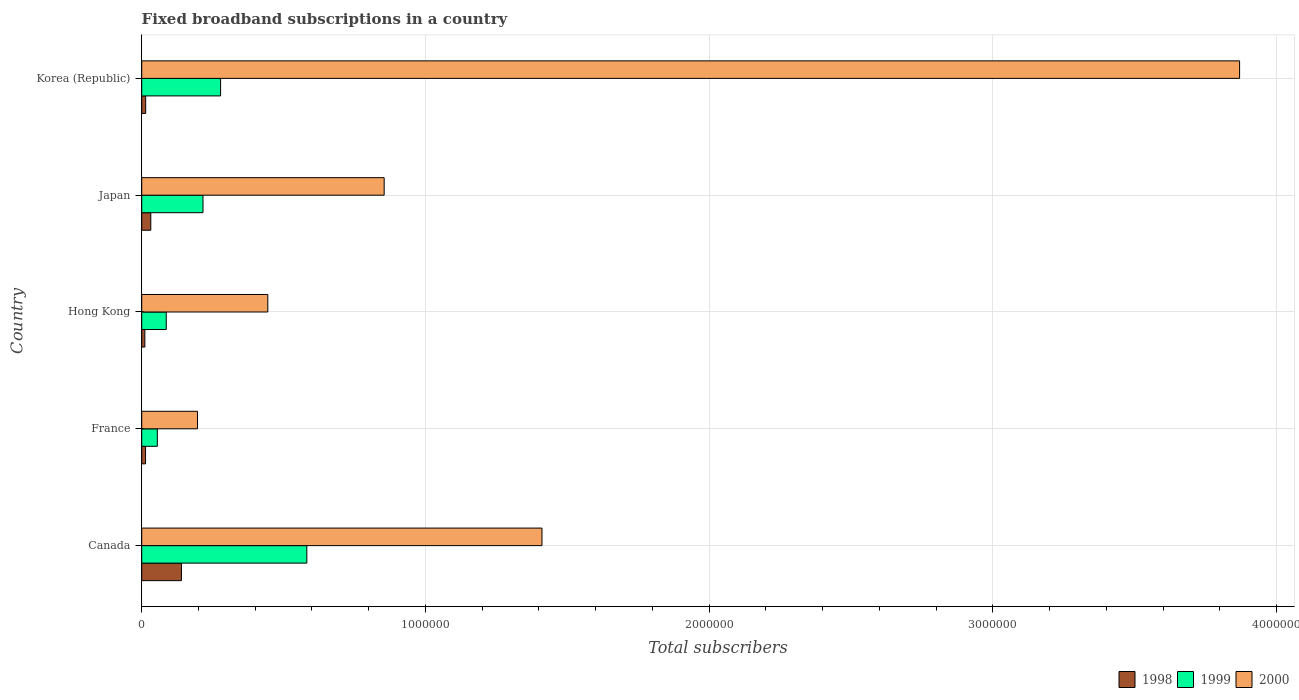Are the number of bars on each tick of the Y-axis equal?
Provide a succinct answer. Yes. How many bars are there on the 5th tick from the top?
Give a very brief answer. 3. What is the label of the 1st group of bars from the top?
Your answer should be compact. Korea (Republic). What is the number of broadband subscriptions in 2000 in France?
Offer a very short reply. 1.97e+05. Across all countries, what is the minimum number of broadband subscriptions in 2000?
Your answer should be compact. 1.97e+05. In which country was the number of broadband subscriptions in 2000 maximum?
Make the answer very short. Korea (Republic). In which country was the number of broadband subscriptions in 2000 minimum?
Give a very brief answer. France. What is the total number of broadband subscriptions in 1999 in the graph?
Offer a very short reply. 1.22e+06. What is the difference between the number of broadband subscriptions in 1998 in France and that in Japan?
Give a very brief answer. -1.85e+04. What is the difference between the number of broadband subscriptions in 1998 in Canada and the number of broadband subscriptions in 1999 in Hong Kong?
Give a very brief answer. 5.35e+04. What is the average number of broadband subscriptions in 1999 per country?
Your answer should be compact. 2.43e+05. What is the difference between the number of broadband subscriptions in 1999 and number of broadband subscriptions in 1998 in Canada?
Offer a very short reply. 4.42e+05. In how many countries, is the number of broadband subscriptions in 2000 greater than 1200000 ?
Ensure brevity in your answer.  2. What is the ratio of the number of broadband subscriptions in 1999 in Canada to that in France?
Make the answer very short. 10.58. Is the number of broadband subscriptions in 1999 in France less than that in Japan?
Make the answer very short. Yes. What is the difference between the highest and the second highest number of broadband subscriptions in 1999?
Ensure brevity in your answer.  3.04e+05. What is the difference between the highest and the lowest number of broadband subscriptions in 1999?
Offer a terse response. 5.27e+05. In how many countries, is the number of broadband subscriptions in 1999 greater than the average number of broadband subscriptions in 1999 taken over all countries?
Offer a very short reply. 2. Is the sum of the number of broadband subscriptions in 2000 in France and Korea (Republic) greater than the maximum number of broadband subscriptions in 1999 across all countries?
Keep it short and to the point. Yes. What does the 3rd bar from the top in Japan represents?
Provide a short and direct response. 1998. What does the 2nd bar from the bottom in Canada represents?
Offer a very short reply. 1999. Is it the case that in every country, the sum of the number of broadband subscriptions in 2000 and number of broadband subscriptions in 1998 is greater than the number of broadband subscriptions in 1999?
Your answer should be very brief. Yes. What is the difference between two consecutive major ticks on the X-axis?
Ensure brevity in your answer.  1.00e+06. Are the values on the major ticks of X-axis written in scientific E-notation?
Ensure brevity in your answer.  No. What is the title of the graph?
Offer a terse response. Fixed broadband subscriptions in a country. What is the label or title of the X-axis?
Make the answer very short. Total subscribers. What is the Total subscribers of 1998 in Canada?
Your response must be concise. 1.40e+05. What is the Total subscribers of 1999 in Canada?
Keep it short and to the point. 5.82e+05. What is the Total subscribers in 2000 in Canada?
Your answer should be very brief. 1.41e+06. What is the Total subscribers of 1998 in France?
Offer a terse response. 1.35e+04. What is the Total subscribers of 1999 in France?
Ensure brevity in your answer.  5.50e+04. What is the Total subscribers of 2000 in France?
Your answer should be compact. 1.97e+05. What is the Total subscribers of 1998 in Hong Kong?
Your response must be concise. 1.10e+04. What is the Total subscribers in 1999 in Hong Kong?
Your response must be concise. 8.65e+04. What is the Total subscribers in 2000 in Hong Kong?
Provide a succinct answer. 4.44e+05. What is the Total subscribers in 1998 in Japan?
Provide a succinct answer. 3.20e+04. What is the Total subscribers of 1999 in Japan?
Make the answer very short. 2.16e+05. What is the Total subscribers of 2000 in Japan?
Provide a short and direct response. 8.55e+05. What is the Total subscribers in 1998 in Korea (Republic)?
Your response must be concise. 1.40e+04. What is the Total subscribers of 1999 in Korea (Republic)?
Offer a terse response. 2.78e+05. What is the Total subscribers of 2000 in Korea (Republic)?
Your response must be concise. 3.87e+06. Across all countries, what is the maximum Total subscribers in 1999?
Offer a very short reply. 5.82e+05. Across all countries, what is the maximum Total subscribers in 2000?
Provide a succinct answer. 3.87e+06. Across all countries, what is the minimum Total subscribers of 1998?
Provide a succinct answer. 1.10e+04. Across all countries, what is the minimum Total subscribers of 1999?
Your response must be concise. 5.50e+04. Across all countries, what is the minimum Total subscribers of 2000?
Your answer should be very brief. 1.97e+05. What is the total Total subscribers in 1998 in the graph?
Your response must be concise. 2.10e+05. What is the total Total subscribers of 1999 in the graph?
Your response must be concise. 1.22e+06. What is the total Total subscribers of 2000 in the graph?
Your answer should be very brief. 6.78e+06. What is the difference between the Total subscribers in 1998 in Canada and that in France?
Give a very brief answer. 1.27e+05. What is the difference between the Total subscribers of 1999 in Canada and that in France?
Keep it short and to the point. 5.27e+05. What is the difference between the Total subscribers in 2000 in Canada and that in France?
Make the answer very short. 1.21e+06. What is the difference between the Total subscribers in 1998 in Canada and that in Hong Kong?
Offer a terse response. 1.29e+05. What is the difference between the Total subscribers in 1999 in Canada and that in Hong Kong?
Provide a short and direct response. 4.96e+05. What is the difference between the Total subscribers in 2000 in Canada and that in Hong Kong?
Give a very brief answer. 9.66e+05. What is the difference between the Total subscribers in 1998 in Canada and that in Japan?
Offer a terse response. 1.08e+05. What is the difference between the Total subscribers in 1999 in Canada and that in Japan?
Provide a succinct answer. 3.66e+05. What is the difference between the Total subscribers of 2000 in Canada and that in Japan?
Make the answer very short. 5.56e+05. What is the difference between the Total subscribers of 1998 in Canada and that in Korea (Republic)?
Your answer should be compact. 1.26e+05. What is the difference between the Total subscribers in 1999 in Canada and that in Korea (Republic)?
Keep it short and to the point. 3.04e+05. What is the difference between the Total subscribers in 2000 in Canada and that in Korea (Republic)?
Your answer should be very brief. -2.46e+06. What is the difference between the Total subscribers in 1998 in France and that in Hong Kong?
Provide a short and direct response. 2464. What is the difference between the Total subscribers of 1999 in France and that in Hong Kong?
Make the answer very short. -3.15e+04. What is the difference between the Total subscribers of 2000 in France and that in Hong Kong?
Provide a succinct answer. -2.48e+05. What is the difference between the Total subscribers in 1998 in France and that in Japan?
Provide a short and direct response. -1.85e+04. What is the difference between the Total subscribers of 1999 in France and that in Japan?
Make the answer very short. -1.61e+05. What is the difference between the Total subscribers in 2000 in France and that in Japan?
Offer a very short reply. -6.58e+05. What is the difference between the Total subscribers in 1998 in France and that in Korea (Republic)?
Offer a terse response. -536. What is the difference between the Total subscribers of 1999 in France and that in Korea (Republic)?
Your response must be concise. -2.23e+05. What is the difference between the Total subscribers in 2000 in France and that in Korea (Republic)?
Keep it short and to the point. -3.67e+06. What is the difference between the Total subscribers of 1998 in Hong Kong and that in Japan?
Give a very brief answer. -2.10e+04. What is the difference between the Total subscribers in 1999 in Hong Kong and that in Japan?
Your answer should be very brief. -1.30e+05. What is the difference between the Total subscribers in 2000 in Hong Kong and that in Japan?
Offer a very short reply. -4.10e+05. What is the difference between the Total subscribers in 1998 in Hong Kong and that in Korea (Republic)?
Offer a very short reply. -3000. What is the difference between the Total subscribers of 1999 in Hong Kong and that in Korea (Republic)?
Ensure brevity in your answer.  -1.92e+05. What is the difference between the Total subscribers of 2000 in Hong Kong and that in Korea (Republic)?
Your answer should be compact. -3.43e+06. What is the difference between the Total subscribers in 1998 in Japan and that in Korea (Republic)?
Ensure brevity in your answer.  1.80e+04. What is the difference between the Total subscribers in 1999 in Japan and that in Korea (Republic)?
Provide a succinct answer. -6.20e+04. What is the difference between the Total subscribers in 2000 in Japan and that in Korea (Republic)?
Give a very brief answer. -3.02e+06. What is the difference between the Total subscribers in 1998 in Canada and the Total subscribers in 1999 in France?
Provide a succinct answer. 8.50e+04. What is the difference between the Total subscribers of 1998 in Canada and the Total subscribers of 2000 in France?
Make the answer very short. -5.66e+04. What is the difference between the Total subscribers in 1999 in Canada and the Total subscribers in 2000 in France?
Your answer should be very brief. 3.85e+05. What is the difference between the Total subscribers in 1998 in Canada and the Total subscribers in 1999 in Hong Kong?
Offer a terse response. 5.35e+04. What is the difference between the Total subscribers in 1998 in Canada and the Total subscribers in 2000 in Hong Kong?
Your response must be concise. -3.04e+05. What is the difference between the Total subscribers in 1999 in Canada and the Total subscribers in 2000 in Hong Kong?
Your response must be concise. 1.38e+05. What is the difference between the Total subscribers of 1998 in Canada and the Total subscribers of 1999 in Japan?
Your response must be concise. -7.60e+04. What is the difference between the Total subscribers of 1998 in Canada and the Total subscribers of 2000 in Japan?
Your answer should be compact. -7.15e+05. What is the difference between the Total subscribers in 1999 in Canada and the Total subscribers in 2000 in Japan?
Provide a short and direct response. -2.73e+05. What is the difference between the Total subscribers in 1998 in Canada and the Total subscribers in 1999 in Korea (Republic)?
Your answer should be very brief. -1.38e+05. What is the difference between the Total subscribers of 1998 in Canada and the Total subscribers of 2000 in Korea (Republic)?
Your answer should be very brief. -3.73e+06. What is the difference between the Total subscribers of 1999 in Canada and the Total subscribers of 2000 in Korea (Republic)?
Ensure brevity in your answer.  -3.29e+06. What is the difference between the Total subscribers in 1998 in France and the Total subscribers in 1999 in Hong Kong?
Provide a succinct answer. -7.30e+04. What is the difference between the Total subscribers of 1998 in France and the Total subscribers of 2000 in Hong Kong?
Keep it short and to the point. -4.31e+05. What is the difference between the Total subscribers in 1999 in France and the Total subscribers in 2000 in Hong Kong?
Provide a succinct answer. -3.89e+05. What is the difference between the Total subscribers of 1998 in France and the Total subscribers of 1999 in Japan?
Your answer should be compact. -2.03e+05. What is the difference between the Total subscribers in 1998 in France and the Total subscribers in 2000 in Japan?
Your answer should be compact. -8.41e+05. What is the difference between the Total subscribers of 1999 in France and the Total subscribers of 2000 in Japan?
Keep it short and to the point. -8.00e+05. What is the difference between the Total subscribers in 1998 in France and the Total subscribers in 1999 in Korea (Republic)?
Ensure brevity in your answer.  -2.65e+05. What is the difference between the Total subscribers in 1998 in France and the Total subscribers in 2000 in Korea (Republic)?
Provide a short and direct response. -3.86e+06. What is the difference between the Total subscribers in 1999 in France and the Total subscribers in 2000 in Korea (Republic)?
Provide a short and direct response. -3.82e+06. What is the difference between the Total subscribers of 1998 in Hong Kong and the Total subscribers of 1999 in Japan?
Provide a short and direct response. -2.05e+05. What is the difference between the Total subscribers of 1998 in Hong Kong and the Total subscribers of 2000 in Japan?
Offer a very short reply. -8.44e+05. What is the difference between the Total subscribers of 1999 in Hong Kong and the Total subscribers of 2000 in Japan?
Give a very brief answer. -7.68e+05. What is the difference between the Total subscribers of 1998 in Hong Kong and the Total subscribers of 1999 in Korea (Republic)?
Keep it short and to the point. -2.67e+05. What is the difference between the Total subscribers in 1998 in Hong Kong and the Total subscribers in 2000 in Korea (Republic)?
Give a very brief answer. -3.86e+06. What is the difference between the Total subscribers of 1999 in Hong Kong and the Total subscribers of 2000 in Korea (Republic)?
Ensure brevity in your answer.  -3.78e+06. What is the difference between the Total subscribers of 1998 in Japan and the Total subscribers of 1999 in Korea (Republic)?
Your answer should be very brief. -2.46e+05. What is the difference between the Total subscribers in 1998 in Japan and the Total subscribers in 2000 in Korea (Republic)?
Offer a terse response. -3.84e+06. What is the difference between the Total subscribers in 1999 in Japan and the Total subscribers in 2000 in Korea (Republic)?
Make the answer very short. -3.65e+06. What is the average Total subscribers of 1998 per country?
Keep it short and to the point. 4.21e+04. What is the average Total subscribers in 1999 per country?
Provide a succinct answer. 2.43e+05. What is the average Total subscribers in 2000 per country?
Ensure brevity in your answer.  1.36e+06. What is the difference between the Total subscribers of 1998 and Total subscribers of 1999 in Canada?
Your response must be concise. -4.42e+05. What is the difference between the Total subscribers of 1998 and Total subscribers of 2000 in Canada?
Offer a terse response. -1.27e+06. What is the difference between the Total subscribers in 1999 and Total subscribers in 2000 in Canada?
Provide a short and direct response. -8.29e+05. What is the difference between the Total subscribers in 1998 and Total subscribers in 1999 in France?
Offer a very short reply. -4.15e+04. What is the difference between the Total subscribers in 1998 and Total subscribers in 2000 in France?
Keep it short and to the point. -1.83e+05. What is the difference between the Total subscribers in 1999 and Total subscribers in 2000 in France?
Your answer should be very brief. -1.42e+05. What is the difference between the Total subscribers of 1998 and Total subscribers of 1999 in Hong Kong?
Ensure brevity in your answer.  -7.55e+04. What is the difference between the Total subscribers of 1998 and Total subscribers of 2000 in Hong Kong?
Make the answer very short. -4.33e+05. What is the difference between the Total subscribers in 1999 and Total subscribers in 2000 in Hong Kong?
Offer a terse response. -3.58e+05. What is the difference between the Total subscribers in 1998 and Total subscribers in 1999 in Japan?
Ensure brevity in your answer.  -1.84e+05. What is the difference between the Total subscribers in 1998 and Total subscribers in 2000 in Japan?
Offer a terse response. -8.23e+05. What is the difference between the Total subscribers in 1999 and Total subscribers in 2000 in Japan?
Your answer should be compact. -6.39e+05. What is the difference between the Total subscribers in 1998 and Total subscribers in 1999 in Korea (Republic)?
Provide a succinct answer. -2.64e+05. What is the difference between the Total subscribers of 1998 and Total subscribers of 2000 in Korea (Republic)?
Provide a short and direct response. -3.86e+06. What is the difference between the Total subscribers of 1999 and Total subscribers of 2000 in Korea (Republic)?
Your answer should be very brief. -3.59e+06. What is the ratio of the Total subscribers of 1998 in Canada to that in France?
Offer a very short reply. 10.4. What is the ratio of the Total subscribers of 1999 in Canada to that in France?
Provide a succinct answer. 10.58. What is the ratio of the Total subscribers of 2000 in Canada to that in France?
Keep it short and to the point. 7.18. What is the ratio of the Total subscribers of 1998 in Canada to that in Hong Kong?
Make the answer very short. 12.73. What is the ratio of the Total subscribers of 1999 in Canada to that in Hong Kong?
Your answer should be compact. 6.73. What is the ratio of the Total subscribers in 2000 in Canada to that in Hong Kong?
Offer a terse response. 3.17. What is the ratio of the Total subscribers in 1998 in Canada to that in Japan?
Your answer should be compact. 4.38. What is the ratio of the Total subscribers in 1999 in Canada to that in Japan?
Offer a terse response. 2.69. What is the ratio of the Total subscribers of 2000 in Canada to that in Japan?
Make the answer very short. 1.65. What is the ratio of the Total subscribers of 1999 in Canada to that in Korea (Republic)?
Ensure brevity in your answer.  2.09. What is the ratio of the Total subscribers in 2000 in Canada to that in Korea (Republic)?
Offer a very short reply. 0.36. What is the ratio of the Total subscribers of 1998 in France to that in Hong Kong?
Provide a short and direct response. 1.22. What is the ratio of the Total subscribers in 1999 in France to that in Hong Kong?
Provide a succinct answer. 0.64. What is the ratio of the Total subscribers of 2000 in France to that in Hong Kong?
Make the answer very short. 0.44. What is the ratio of the Total subscribers of 1998 in France to that in Japan?
Keep it short and to the point. 0.42. What is the ratio of the Total subscribers of 1999 in France to that in Japan?
Your response must be concise. 0.25. What is the ratio of the Total subscribers in 2000 in France to that in Japan?
Your answer should be very brief. 0.23. What is the ratio of the Total subscribers in 1998 in France to that in Korea (Republic)?
Provide a succinct answer. 0.96. What is the ratio of the Total subscribers in 1999 in France to that in Korea (Republic)?
Keep it short and to the point. 0.2. What is the ratio of the Total subscribers in 2000 in France to that in Korea (Republic)?
Provide a succinct answer. 0.05. What is the ratio of the Total subscribers in 1998 in Hong Kong to that in Japan?
Ensure brevity in your answer.  0.34. What is the ratio of the Total subscribers of 1999 in Hong Kong to that in Japan?
Make the answer very short. 0.4. What is the ratio of the Total subscribers of 2000 in Hong Kong to that in Japan?
Give a very brief answer. 0.52. What is the ratio of the Total subscribers of 1998 in Hong Kong to that in Korea (Republic)?
Your answer should be very brief. 0.79. What is the ratio of the Total subscribers of 1999 in Hong Kong to that in Korea (Republic)?
Offer a very short reply. 0.31. What is the ratio of the Total subscribers of 2000 in Hong Kong to that in Korea (Republic)?
Provide a succinct answer. 0.11. What is the ratio of the Total subscribers in 1998 in Japan to that in Korea (Republic)?
Your response must be concise. 2.29. What is the ratio of the Total subscribers in 1999 in Japan to that in Korea (Republic)?
Keep it short and to the point. 0.78. What is the ratio of the Total subscribers in 2000 in Japan to that in Korea (Republic)?
Provide a short and direct response. 0.22. What is the difference between the highest and the second highest Total subscribers of 1998?
Ensure brevity in your answer.  1.08e+05. What is the difference between the highest and the second highest Total subscribers in 1999?
Ensure brevity in your answer.  3.04e+05. What is the difference between the highest and the second highest Total subscribers of 2000?
Give a very brief answer. 2.46e+06. What is the difference between the highest and the lowest Total subscribers of 1998?
Keep it short and to the point. 1.29e+05. What is the difference between the highest and the lowest Total subscribers in 1999?
Keep it short and to the point. 5.27e+05. What is the difference between the highest and the lowest Total subscribers in 2000?
Your answer should be compact. 3.67e+06. 